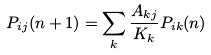<formula> <loc_0><loc_0><loc_500><loc_500>P _ { i j } ( n + 1 ) = \sum _ { k } \frac { A _ { k j } } { K _ { k } } P _ { i k } ( n )</formula> 